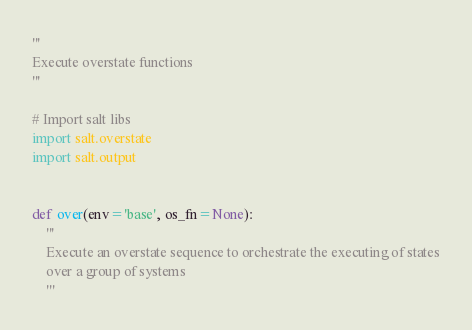Convert code to text. <code><loc_0><loc_0><loc_500><loc_500><_Python_>'''
Execute overstate functions
'''

# Import salt libs
import salt.overstate
import salt.output


def over(env='base', os_fn=None):
    '''
    Execute an overstate sequence to orchestrate the executing of states
    over a group of systems
    '''</code> 